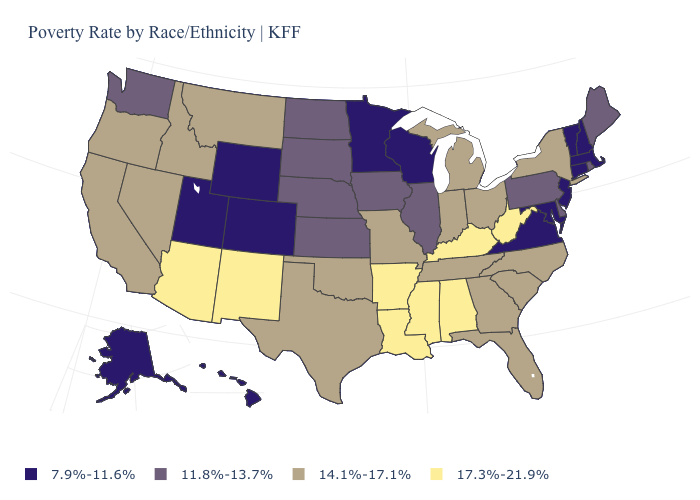What is the highest value in the West ?
Be succinct. 17.3%-21.9%. Which states hav the highest value in the MidWest?
Short answer required. Indiana, Michigan, Missouri, Ohio. Does Alaska have a lower value than Illinois?
Be succinct. Yes. What is the highest value in the USA?
Concise answer only. 17.3%-21.9%. What is the value of Alabama?
Give a very brief answer. 17.3%-21.9%. Name the states that have a value in the range 17.3%-21.9%?
Write a very short answer. Alabama, Arizona, Arkansas, Kentucky, Louisiana, Mississippi, New Mexico, West Virginia. Which states have the lowest value in the MidWest?
Keep it brief. Minnesota, Wisconsin. What is the value of West Virginia?
Write a very short answer. 17.3%-21.9%. What is the value of New Jersey?
Answer briefly. 7.9%-11.6%. What is the value of Kentucky?
Quick response, please. 17.3%-21.9%. How many symbols are there in the legend?
Answer briefly. 4. Does the first symbol in the legend represent the smallest category?
Be succinct. Yes. Does Illinois have the same value as Kansas?
Write a very short answer. Yes. What is the lowest value in the West?
Write a very short answer. 7.9%-11.6%. Does Virginia have a higher value than Massachusetts?
Keep it brief. No. 